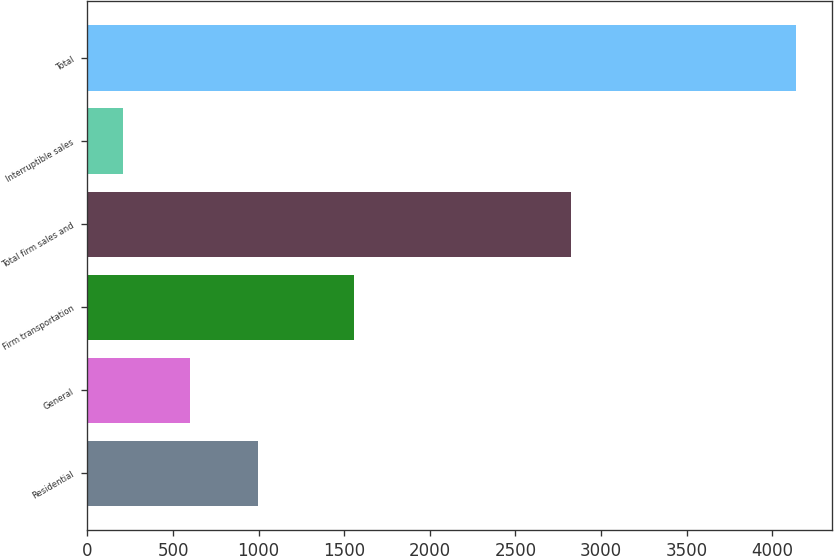Convert chart to OTSL. <chart><loc_0><loc_0><loc_500><loc_500><bar_chart><fcel>Residential<fcel>General<fcel>Firm transportation<fcel>Total firm sales and<fcel>Interruptible sales<fcel>Total<nl><fcel>994.2<fcel>601.1<fcel>1557<fcel>2826<fcel>208<fcel>4139<nl></chart> 